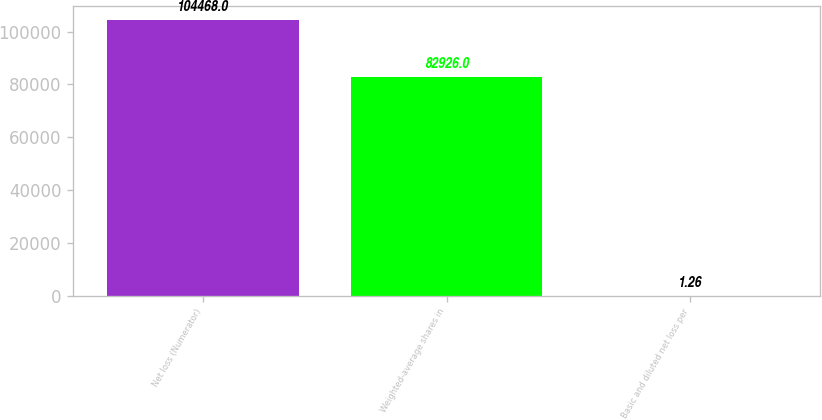Convert chart to OTSL. <chart><loc_0><loc_0><loc_500><loc_500><bar_chart><fcel>Net loss (Numerator)<fcel>Weighted-average shares in<fcel>Basic and diluted net loss per<nl><fcel>104468<fcel>82926<fcel>1.26<nl></chart> 